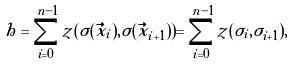<formula> <loc_0><loc_0><loc_500><loc_500>h = \sum _ { i = 0 } ^ { n - 1 } z ( \sigma ( \vec { x } _ { i } ) , \sigma ( \vec { x } _ { i + 1 } ) ) = \sum _ { i = 0 } ^ { n - 1 } z ( \sigma _ { i } , \sigma _ { i + 1 } ) ,</formula> 